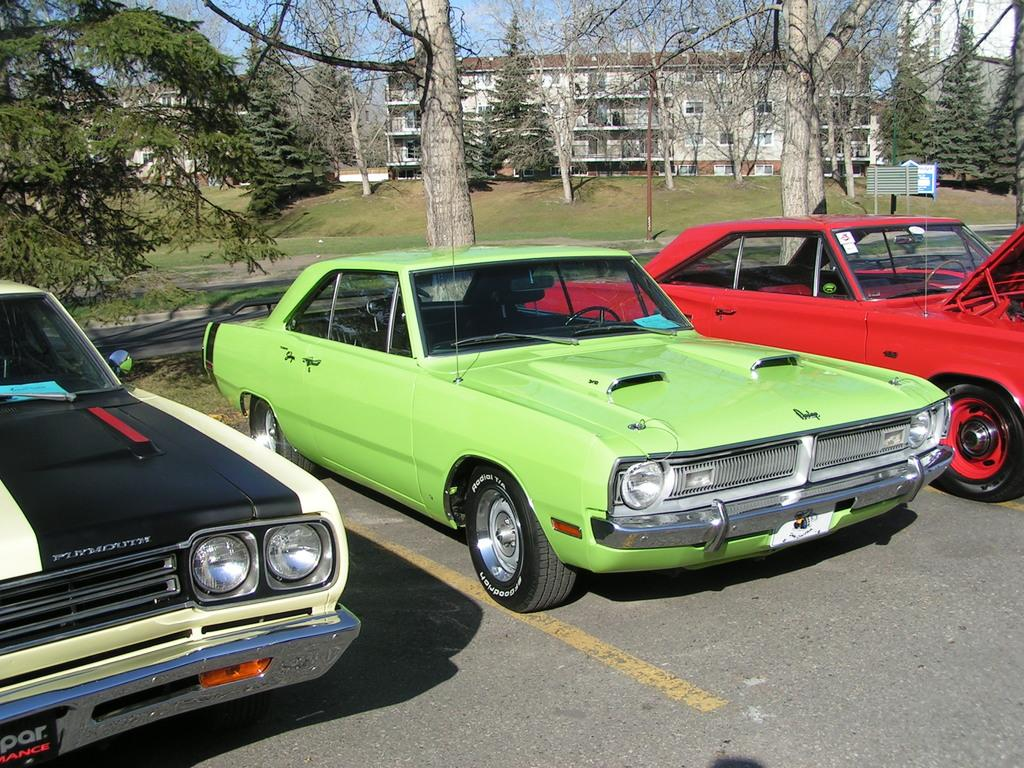What is: What can be seen in the center of the image? There are cars on the road in the center of the image. What is visible in the background of the image? There are trees and a building in the background of the image. What is visible at the top of the image? The sky is visible at the top of the image. What type of locket is hanging from the tree in the image? There is no locket present in the image; it features cars on the road, trees, a building, and the sky. What stage of development is the building in the image? The provided facts do not give information about the stage of development of the building, only that it is visible in the background. 